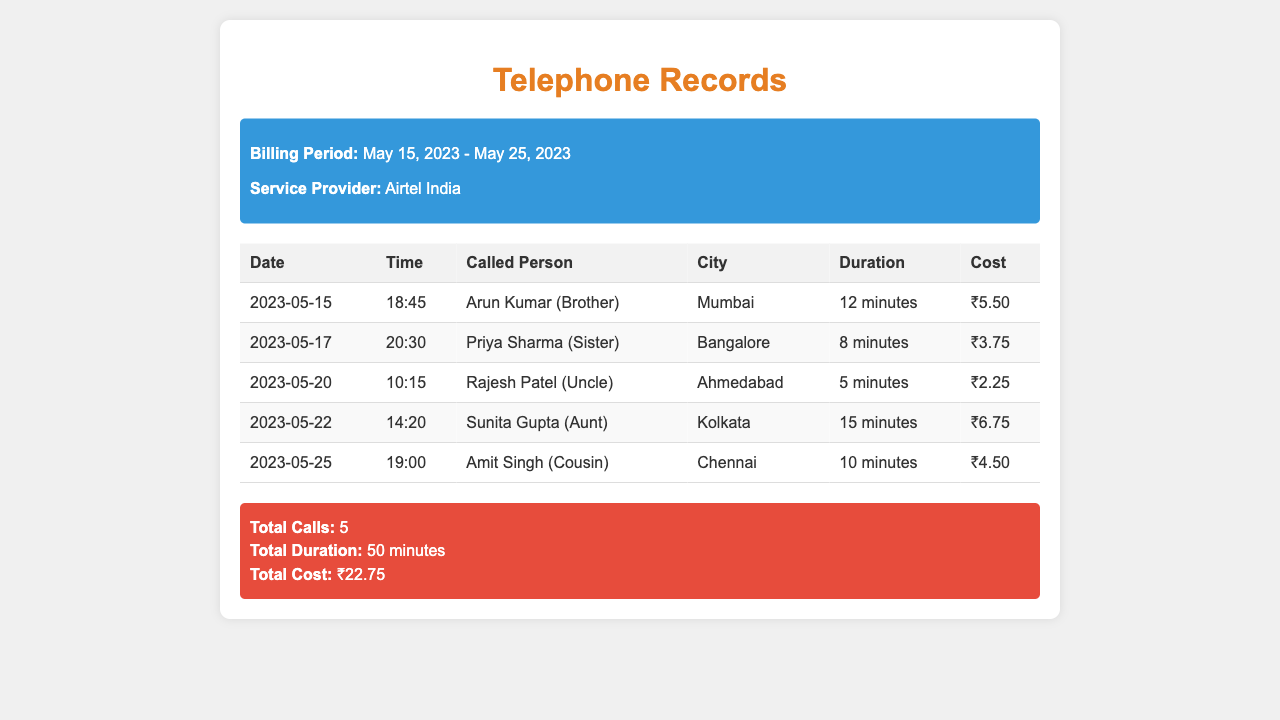What is the total cost of the calls? The total cost is listed at the bottom of the document as the sum of all call costs during the billing period, which is ₹22.75.
Answer: ₹22.75 Who did the longest call go to? The longest call is to Sunita Gupta, with a duration of 15 minutes.
Answer: Sunita Gupta (Aunt) What city is Arun Kumar located in? Arun Kumar is noted as being in Mumbai, which is mentioned in the call details.
Answer: Mumbai How many total calls were made? The total number of calls made is summarized at the end of the table as five calls.
Answer: 5 What was the duration of the call to Amit Singh? The duration for Amit Singh's call is specified in the table as 10 minutes.
Answer: 10 minutes Which family member called from Ahmedabad? The document specifies that Rajesh Patel, who is an Uncle, was called from Ahmedabad.
Answer: Rajesh Patel (Uncle) What date was the call to Priya Sharma made? The call to Priya Sharma is recorded under the date 2023-05-17.
Answer: 2023-05-17 What was the cost of the call made to Sunita Gupta? The cost of Sunita Gupta's call is mentioned as ₹6.75 in the records.
Answer: ₹6.75 What is the total duration of all calls combined? The total duration of the calls is summarized at the end, noted as 50 minutes.
Answer: 50 minutes 